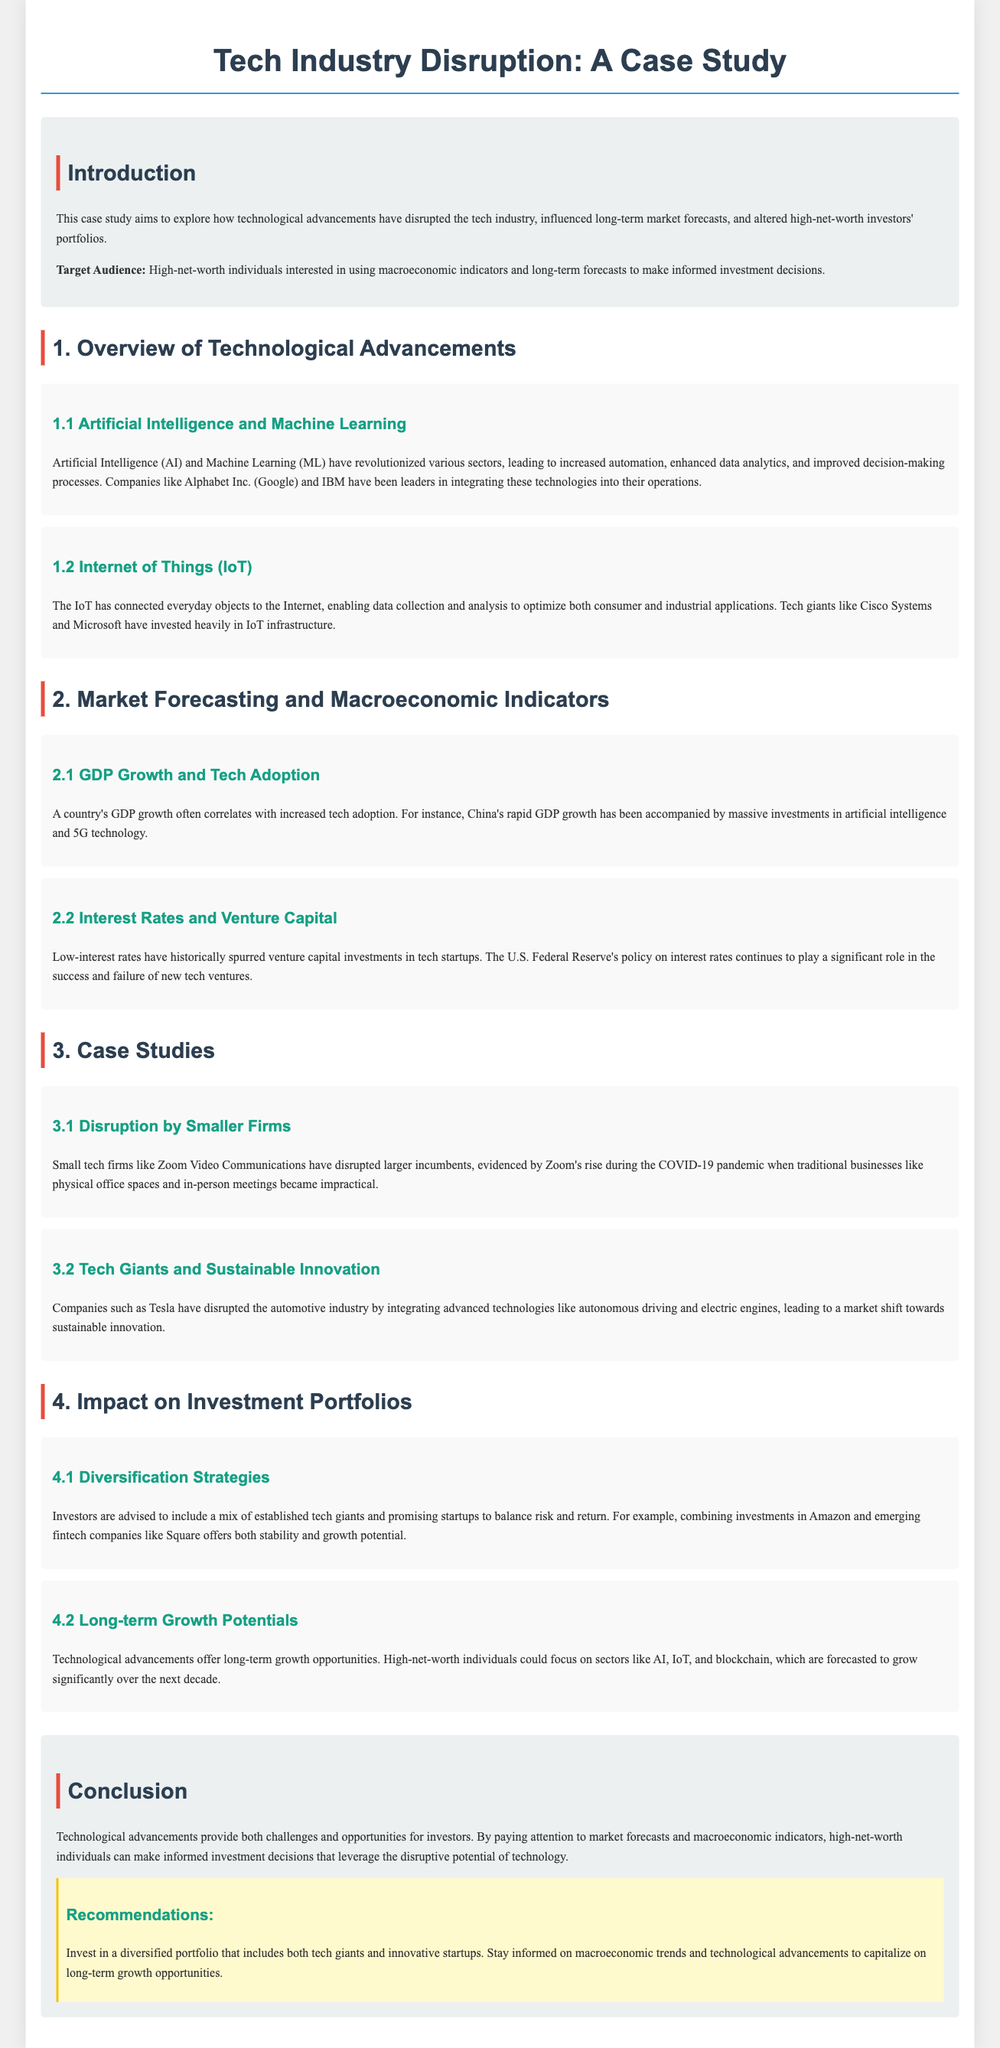What is the main focus of this case study? The case study aims to explore how technological advancements have disrupted the tech industry and influenced investment portfolios.
Answer: Technological advancements Which company is mentioned as a leader in AI integration? The document states that companies like Alphabet Inc. (Google) have been leaders in integrating AI technology.
Answer: Alphabet Inc. (Google) What correlation is discussed in relation to GDP growth? The document mentions a correlation between a country's GDP growth and increased tech adoption, particularly in China.
Answer: Increased tech adoption What is a recommended investment strategy for high-net-worth individuals? The document advises investors to include a mix of established tech giants and promising startups for diversification.
Answer: Diversification strategies Which technological sector is forecasted to grow significantly over the next decade? The document highlights AI, IoT, and blockchain as sectors that are expected to grow significantly.
Answer: AI, IoT, and blockchain What trend does low-interest rates spur in the tech industry? Low-interest rates are noted to historically spur venture capital investments in tech startups.
Answer: Venture capital investments Which case study exemplifies disruption by smaller firms? The document identifies Zoom Video Communications as an example of a smaller firm disrupting larger incumbents.
Answer: Zoom Video Communications What company is specifically mentioned for integrating sustainable innovation? The case study cites Tesla for its role in integrating advanced technologies in the automotive industry.
Answer: Tesla 